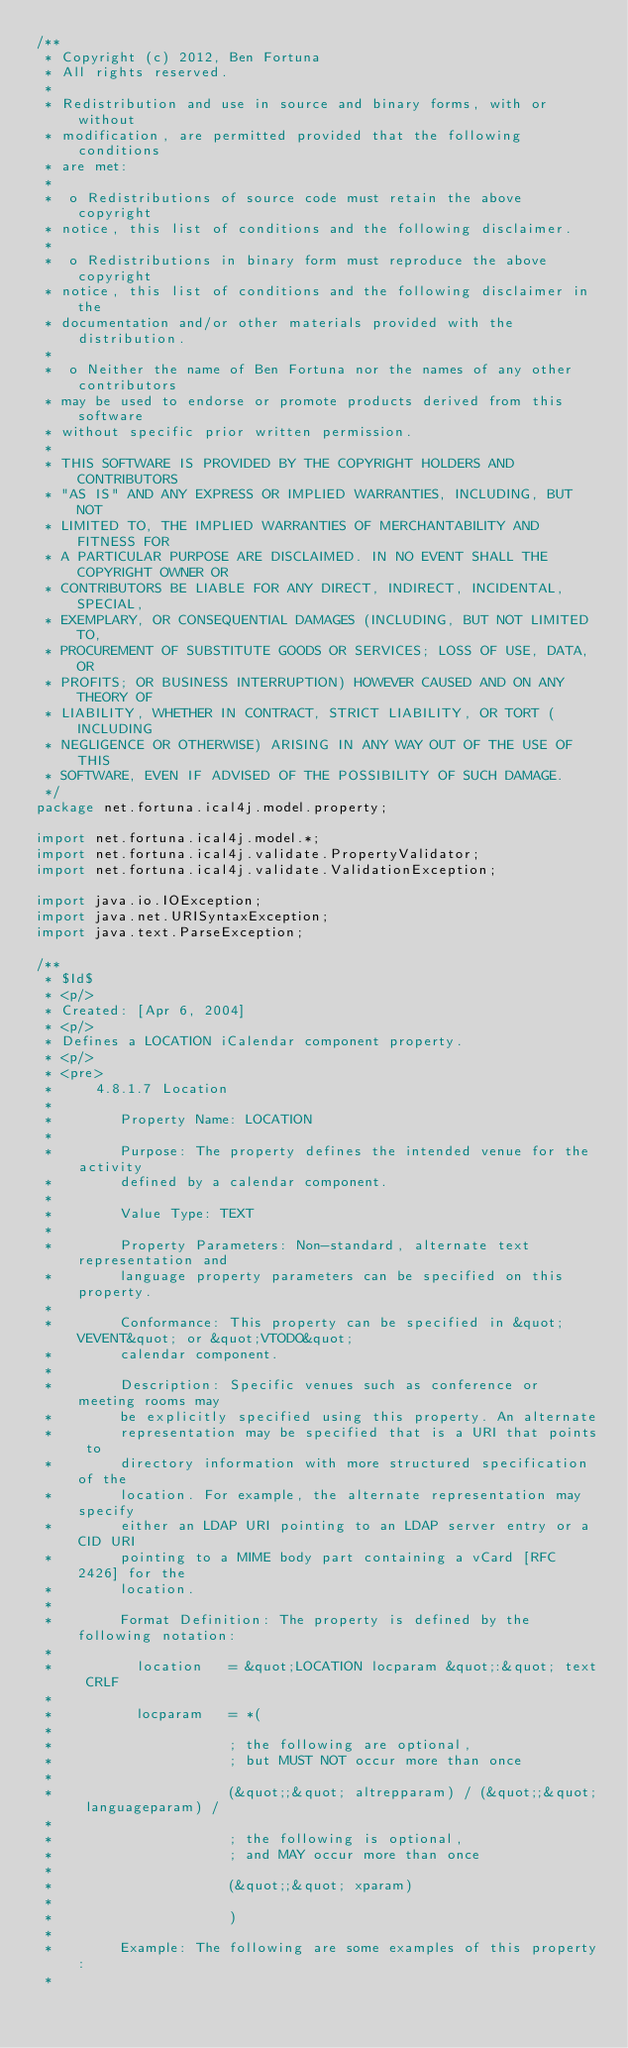<code> <loc_0><loc_0><loc_500><loc_500><_Java_>/**
 * Copyright (c) 2012, Ben Fortuna
 * All rights reserved.
 *
 * Redistribution and use in source and binary forms, with or without
 * modification, are permitted provided that the following conditions
 * are met:
 *
 *  o Redistributions of source code must retain the above copyright
 * notice, this list of conditions and the following disclaimer.
 *
 *  o Redistributions in binary form must reproduce the above copyright
 * notice, this list of conditions and the following disclaimer in the
 * documentation and/or other materials provided with the distribution.
 *
 *  o Neither the name of Ben Fortuna nor the names of any other contributors
 * may be used to endorse or promote products derived from this software
 * without specific prior written permission.
 *
 * THIS SOFTWARE IS PROVIDED BY THE COPYRIGHT HOLDERS AND CONTRIBUTORS
 * "AS IS" AND ANY EXPRESS OR IMPLIED WARRANTIES, INCLUDING, BUT NOT
 * LIMITED TO, THE IMPLIED WARRANTIES OF MERCHANTABILITY AND FITNESS FOR
 * A PARTICULAR PURPOSE ARE DISCLAIMED. IN NO EVENT SHALL THE COPYRIGHT OWNER OR
 * CONTRIBUTORS BE LIABLE FOR ANY DIRECT, INDIRECT, INCIDENTAL, SPECIAL,
 * EXEMPLARY, OR CONSEQUENTIAL DAMAGES (INCLUDING, BUT NOT LIMITED TO,
 * PROCUREMENT OF SUBSTITUTE GOODS OR SERVICES; LOSS OF USE, DATA, OR
 * PROFITS; OR BUSINESS INTERRUPTION) HOWEVER CAUSED AND ON ANY THEORY OF
 * LIABILITY, WHETHER IN CONTRACT, STRICT LIABILITY, OR TORT (INCLUDING
 * NEGLIGENCE OR OTHERWISE) ARISING IN ANY WAY OUT OF THE USE OF THIS
 * SOFTWARE, EVEN IF ADVISED OF THE POSSIBILITY OF SUCH DAMAGE.
 */
package net.fortuna.ical4j.model.property;

import net.fortuna.ical4j.model.*;
import net.fortuna.ical4j.validate.PropertyValidator;
import net.fortuna.ical4j.validate.ValidationException;

import java.io.IOException;
import java.net.URISyntaxException;
import java.text.ParseException;

/**
 * $Id$
 * <p/>
 * Created: [Apr 6, 2004]
 * <p/>
 * Defines a LOCATION iCalendar component property.
 * <p/>
 * <pre>
 *     4.8.1.7 Location
 *
 *        Property Name: LOCATION
 *
 *        Purpose: The property defines the intended venue for the activity
 *        defined by a calendar component.
 *
 *        Value Type: TEXT
 *
 *        Property Parameters: Non-standard, alternate text representation and
 *        language property parameters can be specified on this property.
 *
 *        Conformance: This property can be specified in &quot;VEVENT&quot; or &quot;VTODO&quot;
 *        calendar component.
 *
 *        Description: Specific venues such as conference or meeting rooms may
 *        be explicitly specified using this property. An alternate
 *        representation may be specified that is a URI that points to
 *        directory information with more structured specification of the
 *        location. For example, the alternate representation may specify
 *        either an LDAP URI pointing to an LDAP server entry or a CID URI
 *        pointing to a MIME body part containing a vCard [RFC 2426] for the
 *        location.
 *
 *        Format Definition: The property is defined by the following notation:
 *
 *          location   = &quot;LOCATION locparam &quot;:&quot; text CRLF
 *
 *          locparam   = *(
 *
 *                     ; the following are optional,
 *                     ; but MUST NOT occur more than once
 *
 *                     (&quot;;&quot; altrepparam) / (&quot;;&quot; languageparam) /
 *
 *                     ; the following is optional,
 *                     ; and MAY occur more than once
 *
 *                     (&quot;;&quot; xparam)
 *
 *                     )
 *
 *        Example: The following are some examples of this property:
 *</code> 